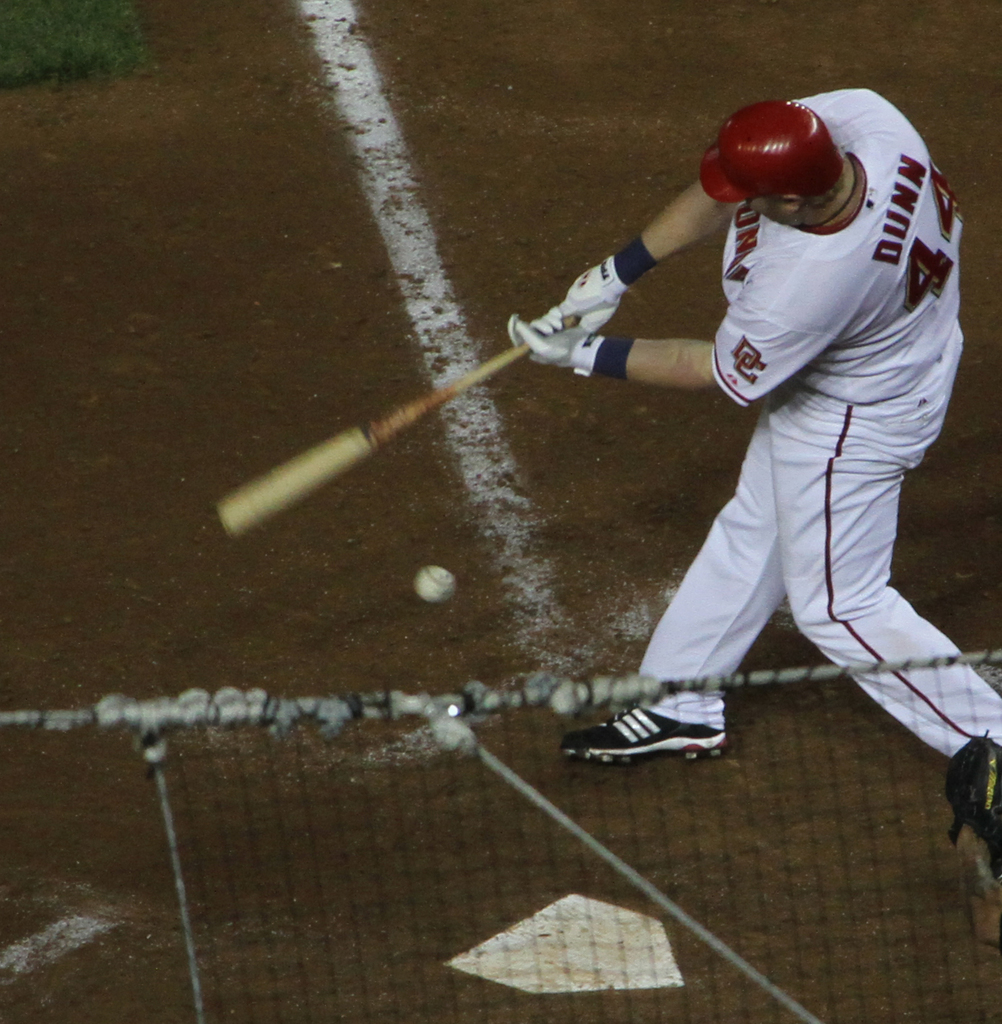Provide a one-sentence caption for the provided image. A baseball player, wearing a red jersey with the number 44, intensely focuses as he swings his bat to hit a fast-approaching ball during a night game. 